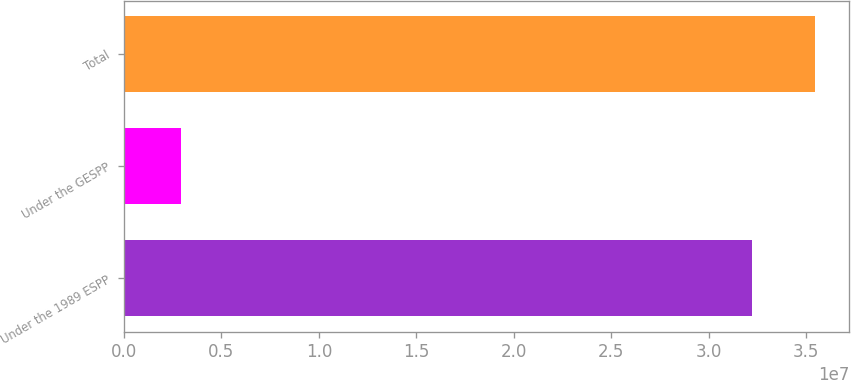Convert chart to OTSL. <chart><loc_0><loc_0><loc_500><loc_500><bar_chart><fcel>Under the 1989 ESPP<fcel>Under the GESPP<fcel>Total<nl><fcel>3.22367e+07<fcel>2.94499e+06<fcel>3.54603e+07<nl></chart> 